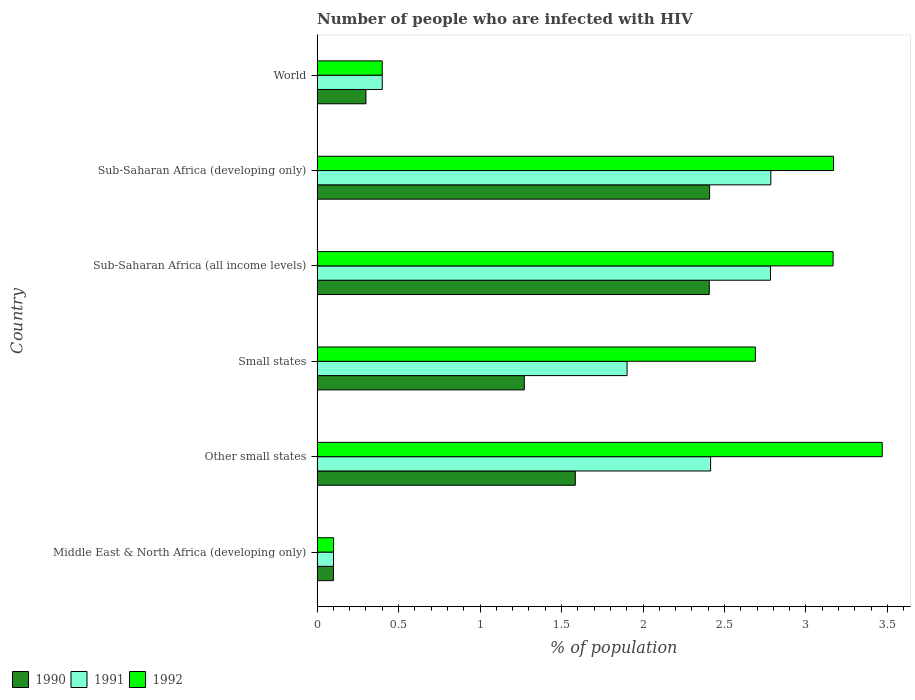Are the number of bars per tick equal to the number of legend labels?
Your answer should be compact. Yes. How many bars are there on the 1st tick from the top?
Provide a succinct answer. 3. What is the label of the 5th group of bars from the top?
Make the answer very short. Other small states. In how many cases, is the number of bars for a given country not equal to the number of legend labels?
Give a very brief answer. 0. What is the percentage of HIV infected population in in 1990 in Sub-Saharan Africa (developing only)?
Offer a terse response. 2.41. Across all countries, what is the maximum percentage of HIV infected population in in 1992?
Provide a short and direct response. 3.47. Across all countries, what is the minimum percentage of HIV infected population in in 1990?
Provide a succinct answer. 0.1. In which country was the percentage of HIV infected population in in 1991 maximum?
Ensure brevity in your answer.  Sub-Saharan Africa (developing only). In which country was the percentage of HIV infected population in in 1991 minimum?
Give a very brief answer. Middle East & North Africa (developing only). What is the total percentage of HIV infected population in in 1992 in the graph?
Provide a succinct answer. 12.99. What is the difference between the percentage of HIV infected population in in 1991 in Other small states and that in Sub-Saharan Africa (developing only)?
Make the answer very short. -0.37. What is the difference between the percentage of HIV infected population in in 1992 in Sub-Saharan Africa (developing only) and the percentage of HIV infected population in in 1991 in World?
Provide a short and direct response. 2.77. What is the average percentage of HIV infected population in in 1991 per country?
Your answer should be very brief. 1.73. What is the difference between the percentage of HIV infected population in in 1991 and percentage of HIV infected population in in 1990 in Sub-Saharan Africa (all income levels)?
Your response must be concise. 0.38. What is the ratio of the percentage of HIV infected population in in 1990 in Sub-Saharan Africa (all income levels) to that in Sub-Saharan Africa (developing only)?
Your answer should be very brief. 1. Is the percentage of HIV infected population in in 1992 in Other small states less than that in Sub-Saharan Africa (all income levels)?
Provide a short and direct response. No. What is the difference between the highest and the second highest percentage of HIV infected population in in 1992?
Your answer should be compact. 0.3. What is the difference between the highest and the lowest percentage of HIV infected population in in 1992?
Offer a very short reply. 3.37. In how many countries, is the percentage of HIV infected population in in 1990 greater than the average percentage of HIV infected population in in 1990 taken over all countries?
Give a very brief answer. 3. Is the sum of the percentage of HIV infected population in in 1991 in Sub-Saharan Africa (developing only) and World greater than the maximum percentage of HIV infected population in in 1992 across all countries?
Offer a very short reply. No. How many bars are there?
Offer a very short reply. 18. Are all the bars in the graph horizontal?
Offer a terse response. Yes. How many countries are there in the graph?
Provide a succinct answer. 6. Are the values on the major ticks of X-axis written in scientific E-notation?
Offer a very short reply. No. Does the graph contain grids?
Give a very brief answer. No. Where does the legend appear in the graph?
Your answer should be very brief. Bottom left. How many legend labels are there?
Your answer should be compact. 3. How are the legend labels stacked?
Ensure brevity in your answer.  Horizontal. What is the title of the graph?
Your response must be concise. Number of people who are infected with HIV. Does "1966" appear as one of the legend labels in the graph?
Make the answer very short. No. What is the label or title of the X-axis?
Offer a terse response. % of population. What is the % of population in 1990 in Middle East & North Africa (developing only)?
Give a very brief answer. 0.1. What is the % of population of 1991 in Middle East & North Africa (developing only)?
Offer a very short reply. 0.1. What is the % of population in 1992 in Middle East & North Africa (developing only)?
Your answer should be compact. 0.1. What is the % of population in 1990 in Other small states?
Offer a terse response. 1.58. What is the % of population of 1991 in Other small states?
Your answer should be compact. 2.41. What is the % of population in 1992 in Other small states?
Your answer should be very brief. 3.47. What is the % of population in 1990 in Small states?
Offer a very short reply. 1.27. What is the % of population of 1991 in Small states?
Offer a terse response. 1.9. What is the % of population in 1992 in Small states?
Provide a succinct answer. 2.69. What is the % of population in 1990 in Sub-Saharan Africa (all income levels)?
Make the answer very short. 2.41. What is the % of population in 1991 in Sub-Saharan Africa (all income levels)?
Give a very brief answer. 2.78. What is the % of population in 1992 in Sub-Saharan Africa (all income levels)?
Your answer should be very brief. 3.17. What is the % of population in 1990 in Sub-Saharan Africa (developing only)?
Provide a succinct answer. 2.41. What is the % of population in 1991 in Sub-Saharan Africa (developing only)?
Keep it short and to the point. 2.78. What is the % of population of 1992 in Sub-Saharan Africa (developing only)?
Keep it short and to the point. 3.17. What is the % of population of 1990 in World?
Offer a terse response. 0.3. What is the % of population of 1992 in World?
Keep it short and to the point. 0.4. Across all countries, what is the maximum % of population in 1990?
Provide a short and direct response. 2.41. Across all countries, what is the maximum % of population of 1991?
Your response must be concise. 2.78. Across all countries, what is the maximum % of population in 1992?
Provide a succinct answer. 3.47. Across all countries, what is the minimum % of population in 1990?
Give a very brief answer. 0.1. Across all countries, what is the minimum % of population in 1991?
Make the answer very short. 0.1. Across all countries, what is the minimum % of population in 1992?
Your answer should be compact. 0.1. What is the total % of population of 1990 in the graph?
Provide a succinct answer. 8.07. What is the total % of population in 1991 in the graph?
Offer a very short reply. 10.38. What is the total % of population of 1992 in the graph?
Give a very brief answer. 12.99. What is the difference between the % of population of 1990 in Middle East & North Africa (developing only) and that in Other small states?
Your answer should be very brief. -1.48. What is the difference between the % of population of 1991 in Middle East & North Africa (developing only) and that in Other small states?
Offer a terse response. -2.31. What is the difference between the % of population in 1992 in Middle East & North Africa (developing only) and that in Other small states?
Give a very brief answer. -3.37. What is the difference between the % of population in 1990 in Middle East & North Africa (developing only) and that in Small states?
Ensure brevity in your answer.  -1.17. What is the difference between the % of population of 1991 in Middle East & North Africa (developing only) and that in Small states?
Ensure brevity in your answer.  -1.8. What is the difference between the % of population of 1992 in Middle East & North Africa (developing only) and that in Small states?
Provide a short and direct response. -2.59. What is the difference between the % of population of 1990 in Middle East & North Africa (developing only) and that in Sub-Saharan Africa (all income levels)?
Offer a very short reply. -2.31. What is the difference between the % of population in 1991 in Middle East & North Africa (developing only) and that in Sub-Saharan Africa (all income levels)?
Keep it short and to the point. -2.68. What is the difference between the % of population in 1992 in Middle East & North Africa (developing only) and that in Sub-Saharan Africa (all income levels)?
Your answer should be very brief. -3.06. What is the difference between the % of population of 1990 in Middle East & North Africa (developing only) and that in Sub-Saharan Africa (developing only)?
Your answer should be compact. -2.31. What is the difference between the % of population of 1991 in Middle East & North Africa (developing only) and that in Sub-Saharan Africa (developing only)?
Give a very brief answer. -2.68. What is the difference between the % of population in 1992 in Middle East & North Africa (developing only) and that in Sub-Saharan Africa (developing only)?
Provide a succinct answer. -3.07. What is the difference between the % of population of 1990 in Middle East & North Africa (developing only) and that in World?
Provide a short and direct response. -0.2. What is the difference between the % of population of 1991 in Middle East & North Africa (developing only) and that in World?
Your answer should be compact. -0.3. What is the difference between the % of population in 1992 in Middle East & North Africa (developing only) and that in World?
Give a very brief answer. -0.3. What is the difference between the % of population in 1990 in Other small states and that in Small states?
Provide a short and direct response. 0.31. What is the difference between the % of population in 1991 in Other small states and that in Small states?
Ensure brevity in your answer.  0.51. What is the difference between the % of population of 1992 in Other small states and that in Small states?
Provide a short and direct response. 0.78. What is the difference between the % of population of 1990 in Other small states and that in Sub-Saharan Africa (all income levels)?
Give a very brief answer. -0.82. What is the difference between the % of population in 1991 in Other small states and that in Sub-Saharan Africa (all income levels)?
Provide a short and direct response. -0.37. What is the difference between the % of population in 1992 in Other small states and that in Sub-Saharan Africa (all income levels)?
Provide a succinct answer. 0.3. What is the difference between the % of population of 1990 in Other small states and that in Sub-Saharan Africa (developing only)?
Your answer should be compact. -0.82. What is the difference between the % of population of 1991 in Other small states and that in Sub-Saharan Africa (developing only)?
Your answer should be compact. -0.37. What is the difference between the % of population in 1992 in Other small states and that in Sub-Saharan Africa (developing only)?
Give a very brief answer. 0.3. What is the difference between the % of population of 1990 in Other small states and that in World?
Your answer should be very brief. 1.28. What is the difference between the % of population of 1991 in Other small states and that in World?
Offer a very short reply. 2.01. What is the difference between the % of population of 1992 in Other small states and that in World?
Your answer should be compact. 3.07. What is the difference between the % of population in 1990 in Small states and that in Sub-Saharan Africa (all income levels)?
Keep it short and to the point. -1.13. What is the difference between the % of population of 1991 in Small states and that in Sub-Saharan Africa (all income levels)?
Give a very brief answer. -0.88. What is the difference between the % of population in 1992 in Small states and that in Sub-Saharan Africa (all income levels)?
Offer a very short reply. -0.48. What is the difference between the % of population of 1990 in Small states and that in Sub-Saharan Africa (developing only)?
Your response must be concise. -1.14. What is the difference between the % of population in 1991 in Small states and that in Sub-Saharan Africa (developing only)?
Provide a succinct answer. -0.88. What is the difference between the % of population of 1992 in Small states and that in Sub-Saharan Africa (developing only)?
Give a very brief answer. -0.48. What is the difference between the % of population in 1990 in Small states and that in World?
Give a very brief answer. 0.97. What is the difference between the % of population of 1991 in Small states and that in World?
Your answer should be very brief. 1.5. What is the difference between the % of population of 1992 in Small states and that in World?
Give a very brief answer. 2.29. What is the difference between the % of population of 1990 in Sub-Saharan Africa (all income levels) and that in Sub-Saharan Africa (developing only)?
Give a very brief answer. -0. What is the difference between the % of population of 1991 in Sub-Saharan Africa (all income levels) and that in Sub-Saharan Africa (developing only)?
Your answer should be compact. -0. What is the difference between the % of population of 1992 in Sub-Saharan Africa (all income levels) and that in Sub-Saharan Africa (developing only)?
Your answer should be very brief. -0. What is the difference between the % of population in 1990 in Sub-Saharan Africa (all income levels) and that in World?
Offer a terse response. 2.11. What is the difference between the % of population in 1991 in Sub-Saharan Africa (all income levels) and that in World?
Provide a succinct answer. 2.38. What is the difference between the % of population in 1992 in Sub-Saharan Africa (all income levels) and that in World?
Offer a very short reply. 2.77. What is the difference between the % of population of 1990 in Sub-Saharan Africa (developing only) and that in World?
Provide a short and direct response. 2.11. What is the difference between the % of population of 1991 in Sub-Saharan Africa (developing only) and that in World?
Ensure brevity in your answer.  2.38. What is the difference between the % of population in 1992 in Sub-Saharan Africa (developing only) and that in World?
Provide a short and direct response. 2.77. What is the difference between the % of population in 1990 in Middle East & North Africa (developing only) and the % of population in 1991 in Other small states?
Provide a short and direct response. -2.31. What is the difference between the % of population in 1990 in Middle East & North Africa (developing only) and the % of population in 1992 in Other small states?
Provide a short and direct response. -3.37. What is the difference between the % of population in 1991 in Middle East & North Africa (developing only) and the % of population in 1992 in Other small states?
Ensure brevity in your answer.  -3.37. What is the difference between the % of population in 1990 in Middle East & North Africa (developing only) and the % of population in 1991 in Small states?
Give a very brief answer. -1.8. What is the difference between the % of population of 1990 in Middle East & North Africa (developing only) and the % of population of 1992 in Small states?
Keep it short and to the point. -2.59. What is the difference between the % of population in 1991 in Middle East & North Africa (developing only) and the % of population in 1992 in Small states?
Give a very brief answer. -2.59. What is the difference between the % of population in 1990 in Middle East & North Africa (developing only) and the % of population in 1991 in Sub-Saharan Africa (all income levels)?
Your answer should be compact. -2.68. What is the difference between the % of population of 1990 in Middle East & North Africa (developing only) and the % of population of 1992 in Sub-Saharan Africa (all income levels)?
Provide a short and direct response. -3.07. What is the difference between the % of population in 1991 in Middle East & North Africa (developing only) and the % of population in 1992 in Sub-Saharan Africa (all income levels)?
Offer a terse response. -3.07. What is the difference between the % of population of 1990 in Middle East & North Africa (developing only) and the % of population of 1991 in Sub-Saharan Africa (developing only)?
Make the answer very short. -2.68. What is the difference between the % of population in 1990 in Middle East & North Africa (developing only) and the % of population in 1992 in Sub-Saharan Africa (developing only)?
Your answer should be compact. -3.07. What is the difference between the % of population of 1991 in Middle East & North Africa (developing only) and the % of population of 1992 in Sub-Saharan Africa (developing only)?
Make the answer very short. -3.07. What is the difference between the % of population of 1990 in Middle East & North Africa (developing only) and the % of population of 1991 in World?
Your answer should be very brief. -0.3. What is the difference between the % of population of 1990 in Middle East & North Africa (developing only) and the % of population of 1992 in World?
Keep it short and to the point. -0.3. What is the difference between the % of population of 1991 in Middle East & North Africa (developing only) and the % of population of 1992 in World?
Ensure brevity in your answer.  -0.3. What is the difference between the % of population in 1990 in Other small states and the % of population in 1991 in Small states?
Offer a terse response. -0.32. What is the difference between the % of population in 1990 in Other small states and the % of population in 1992 in Small states?
Provide a succinct answer. -1.1. What is the difference between the % of population of 1991 in Other small states and the % of population of 1992 in Small states?
Provide a succinct answer. -0.27. What is the difference between the % of population in 1990 in Other small states and the % of population in 1991 in Sub-Saharan Africa (all income levels)?
Your answer should be compact. -1.2. What is the difference between the % of population in 1990 in Other small states and the % of population in 1992 in Sub-Saharan Africa (all income levels)?
Provide a short and direct response. -1.58. What is the difference between the % of population of 1991 in Other small states and the % of population of 1992 in Sub-Saharan Africa (all income levels)?
Keep it short and to the point. -0.75. What is the difference between the % of population of 1990 in Other small states and the % of population of 1991 in Sub-Saharan Africa (developing only)?
Your response must be concise. -1.2. What is the difference between the % of population of 1990 in Other small states and the % of population of 1992 in Sub-Saharan Africa (developing only)?
Offer a very short reply. -1.58. What is the difference between the % of population in 1991 in Other small states and the % of population in 1992 in Sub-Saharan Africa (developing only)?
Provide a succinct answer. -0.75. What is the difference between the % of population of 1990 in Other small states and the % of population of 1991 in World?
Your response must be concise. 1.18. What is the difference between the % of population of 1990 in Other small states and the % of population of 1992 in World?
Keep it short and to the point. 1.18. What is the difference between the % of population in 1991 in Other small states and the % of population in 1992 in World?
Provide a short and direct response. 2.01. What is the difference between the % of population of 1990 in Small states and the % of population of 1991 in Sub-Saharan Africa (all income levels)?
Provide a short and direct response. -1.51. What is the difference between the % of population of 1990 in Small states and the % of population of 1992 in Sub-Saharan Africa (all income levels)?
Make the answer very short. -1.89. What is the difference between the % of population in 1991 in Small states and the % of population in 1992 in Sub-Saharan Africa (all income levels)?
Give a very brief answer. -1.26. What is the difference between the % of population in 1990 in Small states and the % of population in 1991 in Sub-Saharan Africa (developing only)?
Make the answer very short. -1.51. What is the difference between the % of population in 1990 in Small states and the % of population in 1992 in Sub-Saharan Africa (developing only)?
Make the answer very short. -1.9. What is the difference between the % of population in 1991 in Small states and the % of population in 1992 in Sub-Saharan Africa (developing only)?
Provide a succinct answer. -1.27. What is the difference between the % of population of 1990 in Small states and the % of population of 1991 in World?
Offer a terse response. 0.87. What is the difference between the % of population in 1990 in Small states and the % of population in 1992 in World?
Keep it short and to the point. 0.87. What is the difference between the % of population of 1991 in Small states and the % of population of 1992 in World?
Your answer should be very brief. 1.5. What is the difference between the % of population in 1990 in Sub-Saharan Africa (all income levels) and the % of population in 1991 in Sub-Saharan Africa (developing only)?
Offer a terse response. -0.38. What is the difference between the % of population in 1990 in Sub-Saharan Africa (all income levels) and the % of population in 1992 in Sub-Saharan Africa (developing only)?
Keep it short and to the point. -0.76. What is the difference between the % of population in 1991 in Sub-Saharan Africa (all income levels) and the % of population in 1992 in Sub-Saharan Africa (developing only)?
Offer a very short reply. -0.39. What is the difference between the % of population of 1990 in Sub-Saharan Africa (all income levels) and the % of population of 1991 in World?
Provide a short and direct response. 2.01. What is the difference between the % of population of 1990 in Sub-Saharan Africa (all income levels) and the % of population of 1992 in World?
Provide a succinct answer. 2.01. What is the difference between the % of population of 1991 in Sub-Saharan Africa (all income levels) and the % of population of 1992 in World?
Give a very brief answer. 2.38. What is the difference between the % of population in 1990 in Sub-Saharan Africa (developing only) and the % of population in 1991 in World?
Provide a succinct answer. 2.01. What is the difference between the % of population in 1990 in Sub-Saharan Africa (developing only) and the % of population in 1992 in World?
Offer a terse response. 2.01. What is the difference between the % of population of 1991 in Sub-Saharan Africa (developing only) and the % of population of 1992 in World?
Ensure brevity in your answer.  2.38. What is the average % of population in 1990 per country?
Your answer should be compact. 1.35. What is the average % of population of 1991 per country?
Offer a terse response. 1.73. What is the average % of population in 1992 per country?
Offer a terse response. 2.17. What is the difference between the % of population in 1990 and % of population in 1991 in Middle East & North Africa (developing only)?
Provide a short and direct response. -0. What is the difference between the % of population of 1990 and % of population of 1992 in Middle East & North Africa (developing only)?
Provide a short and direct response. -0. What is the difference between the % of population in 1991 and % of population in 1992 in Middle East & North Africa (developing only)?
Offer a very short reply. -0. What is the difference between the % of population in 1990 and % of population in 1991 in Other small states?
Keep it short and to the point. -0.83. What is the difference between the % of population in 1990 and % of population in 1992 in Other small states?
Your answer should be very brief. -1.88. What is the difference between the % of population of 1991 and % of population of 1992 in Other small states?
Offer a terse response. -1.05. What is the difference between the % of population of 1990 and % of population of 1991 in Small states?
Keep it short and to the point. -0.63. What is the difference between the % of population in 1990 and % of population in 1992 in Small states?
Make the answer very short. -1.42. What is the difference between the % of population in 1991 and % of population in 1992 in Small states?
Provide a short and direct response. -0.79. What is the difference between the % of population in 1990 and % of population in 1991 in Sub-Saharan Africa (all income levels)?
Provide a succinct answer. -0.38. What is the difference between the % of population in 1990 and % of population in 1992 in Sub-Saharan Africa (all income levels)?
Your answer should be compact. -0.76. What is the difference between the % of population of 1991 and % of population of 1992 in Sub-Saharan Africa (all income levels)?
Keep it short and to the point. -0.38. What is the difference between the % of population in 1990 and % of population in 1991 in Sub-Saharan Africa (developing only)?
Offer a very short reply. -0.38. What is the difference between the % of population in 1990 and % of population in 1992 in Sub-Saharan Africa (developing only)?
Your answer should be very brief. -0.76. What is the difference between the % of population of 1991 and % of population of 1992 in Sub-Saharan Africa (developing only)?
Ensure brevity in your answer.  -0.38. What is the difference between the % of population of 1990 and % of population of 1992 in World?
Offer a terse response. -0.1. What is the ratio of the % of population of 1990 in Middle East & North Africa (developing only) to that in Other small states?
Make the answer very short. 0.06. What is the ratio of the % of population of 1991 in Middle East & North Africa (developing only) to that in Other small states?
Offer a terse response. 0.04. What is the ratio of the % of population in 1992 in Middle East & North Africa (developing only) to that in Other small states?
Make the answer very short. 0.03. What is the ratio of the % of population in 1990 in Middle East & North Africa (developing only) to that in Small states?
Your answer should be compact. 0.08. What is the ratio of the % of population of 1991 in Middle East & North Africa (developing only) to that in Small states?
Your answer should be compact. 0.05. What is the ratio of the % of population in 1992 in Middle East & North Africa (developing only) to that in Small states?
Offer a very short reply. 0.04. What is the ratio of the % of population in 1990 in Middle East & North Africa (developing only) to that in Sub-Saharan Africa (all income levels)?
Ensure brevity in your answer.  0.04. What is the ratio of the % of population of 1991 in Middle East & North Africa (developing only) to that in Sub-Saharan Africa (all income levels)?
Ensure brevity in your answer.  0.04. What is the ratio of the % of population in 1992 in Middle East & North Africa (developing only) to that in Sub-Saharan Africa (all income levels)?
Your response must be concise. 0.03. What is the ratio of the % of population in 1990 in Middle East & North Africa (developing only) to that in Sub-Saharan Africa (developing only)?
Your answer should be compact. 0.04. What is the ratio of the % of population in 1991 in Middle East & North Africa (developing only) to that in Sub-Saharan Africa (developing only)?
Give a very brief answer. 0.04. What is the ratio of the % of population of 1992 in Middle East & North Africa (developing only) to that in Sub-Saharan Africa (developing only)?
Your answer should be very brief. 0.03. What is the ratio of the % of population of 1990 in Middle East & North Africa (developing only) to that in World?
Offer a very short reply. 0.34. What is the ratio of the % of population in 1991 in Middle East & North Africa (developing only) to that in World?
Offer a terse response. 0.25. What is the ratio of the % of population of 1992 in Middle East & North Africa (developing only) to that in World?
Offer a very short reply. 0.25. What is the ratio of the % of population in 1990 in Other small states to that in Small states?
Keep it short and to the point. 1.25. What is the ratio of the % of population of 1991 in Other small states to that in Small states?
Your response must be concise. 1.27. What is the ratio of the % of population in 1992 in Other small states to that in Small states?
Make the answer very short. 1.29. What is the ratio of the % of population of 1990 in Other small states to that in Sub-Saharan Africa (all income levels)?
Your answer should be very brief. 0.66. What is the ratio of the % of population in 1991 in Other small states to that in Sub-Saharan Africa (all income levels)?
Offer a terse response. 0.87. What is the ratio of the % of population in 1992 in Other small states to that in Sub-Saharan Africa (all income levels)?
Give a very brief answer. 1.1. What is the ratio of the % of population in 1990 in Other small states to that in Sub-Saharan Africa (developing only)?
Provide a succinct answer. 0.66. What is the ratio of the % of population of 1991 in Other small states to that in Sub-Saharan Africa (developing only)?
Provide a short and direct response. 0.87. What is the ratio of the % of population of 1992 in Other small states to that in Sub-Saharan Africa (developing only)?
Keep it short and to the point. 1.09. What is the ratio of the % of population of 1990 in Other small states to that in World?
Provide a succinct answer. 5.28. What is the ratio of the % of population of 1991 in Other small states to that in World?
Ensure brevity in your answer.  6.04. What is the ratio of the % of population in 1992 in Other small states to that in World?
Your response must be concise. 8.67. What is the ratio of the % of population in 1990 in Small states to that in Sub-Saharan Africa (all income levels)?
Offer a very short reply. 0.53. What is the ratio of the % of population in 1991 in Small states to that in Sub-Saharan Africa (all income levels)?
Keep it short and to the point. 0.68. What is the ratio of the % of population in 1992 in Small states to that in Sub-Saharan Africa (all income levels)?
Offer a terse response. 0.85. What is the ratio of the % of population of 1990 in Small states to that in Sub-Saharan Africa (developing only)?
Ensure brevity in your answer.  0.53. What is the ratio of the % of population of 1991 in Small states to that in Sub-Saharan Africa (developing only)?
Your answer should be very brief. 0.68. What is the ratio of the % of population of 1992 in Small states to that in Sub-Saharan Africa (developing only)?
Provide a short and direct response. 0.85. What is the ratio of the % of population of 1990 in Small states to that in World?
Provide a succinct answer. 4.24. What is the ratio of the % of population of 1991 in Small states to that in World?
Your answer should be compact. 4.76. What is the ratio of the % of population of 1992 in Small states to that in World?
Your answer should be very brief. 6.72. What is the ratio of the % of population of 1990 in Sub-Saharan Africa (all income levels) to that in World?
Offer a terse response. 8.02. What is the ratio of the % of population in 1991 in Sub-Saharan Africa (all income levels) to that in World?
Make the answer very short. 6.96. What is the ratio of the % of population of 1992 in Sub-Saharan Africa (all income levels) to that in World?
Provide a short and direct response. 7.92. What is the ratio of the % of population in 1990 in Sub-Saharan Africa (developing only) to that in World?
Keep it short and to the point. 8.03. What is the ratio of the % of population in 1991 in Sub-Saharan Africa (developing only) to that in World?
Ensure brevity in your answer.  6.96. What is the ratio of the % of population of 1992 in Sub-Saharan Africa (developing only) to that in World?
Provide a succinct answer. 7.92. What is the difference between the highest and the second highest % of population in 1990?
Your answer should be very brief. 0. What is the difference between the highest and the second highest % of population of 1991?
Make the answer very short. 0. What is the difference between the highest and the second highest % of population in 1992?
Offer a terse response. 0.3. What is the difference between the highest and the lowest % of population of 1990?
Offer a terse response. 2.31. What is the difference between the highest and the lowest % of population of 1991?
Offer a terse response. 2.68. What is the difference between the highest and the lowest % of population in 1992?
Offer a terse response. 3.37. 